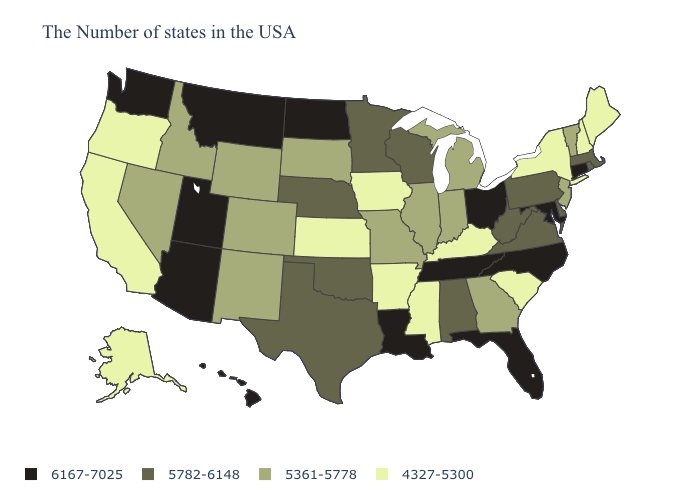Does the first symbol in the legend represent the smallest category?
Be succinct. No. What is the highest value in the USA?
Give a very brief answer. 6167-7025. What is the value of New York?
Quick response, please. 4327-5300. Name the states that have a value in the range 6167-7025?
Short answer required. Connecticut, Maryland, North Carolina, Ohio, Florida, Tennessee, Louisiana, North Dakota, Utah, Montana, Arizona, Washington, Hawaii. Which states hav the highest value in the MidWest?
Be succinct. Ohio, North Dakota. Does the map have missing data?
Short answer required. No. Among the states that border Rhode Island , does Connecticut have the lowest value?
Write a very short answer. No. Does Maryland have the same value as Connecticut?
Write a very short answer. Yes. What is the value of Georgia?
Concise answer only. 5361-5778. Name the states that have a value in the range 4327-5300?
Be succinct. Maine, New Hampshire, New York, South Carolina, Kentucky, Mississippi, Arkansas, Iowa, Kansas, California, Oregon, Alaska. What is the lowest value in the MidWest?
Write a very short answer. 4327-5300. Among the states that border Iowa , which have the lowest value?
Write a very short answer. Illinois, Missouri, South Dakota. What is the value of Maryland?
Short answer required. 6167-7025. Name the states that have a value in the range 6167-7025?
Quick response, please. Connecticut, Maryland, North Carolina, Ohio, Florida, Tennessee, Louisiana, North Dakota, Utah, Montana, Arizona, Washington, Hawaii. 